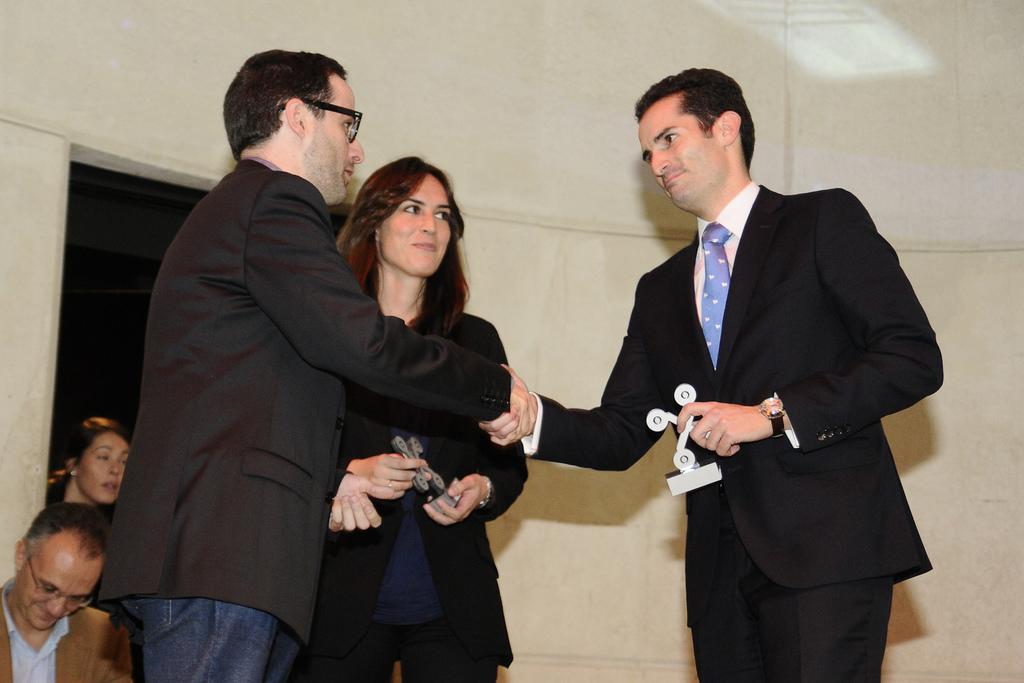Can you describe this image briefly? In the middle of the image few people are standing, smiling and holding something in their hands. Behind them there is wall. In the bottom left corner of the image few people are sitting. 